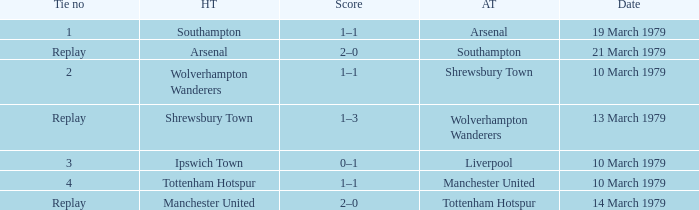What was the score for the tie that had Shrewsbury Town as home team? 1–3. 